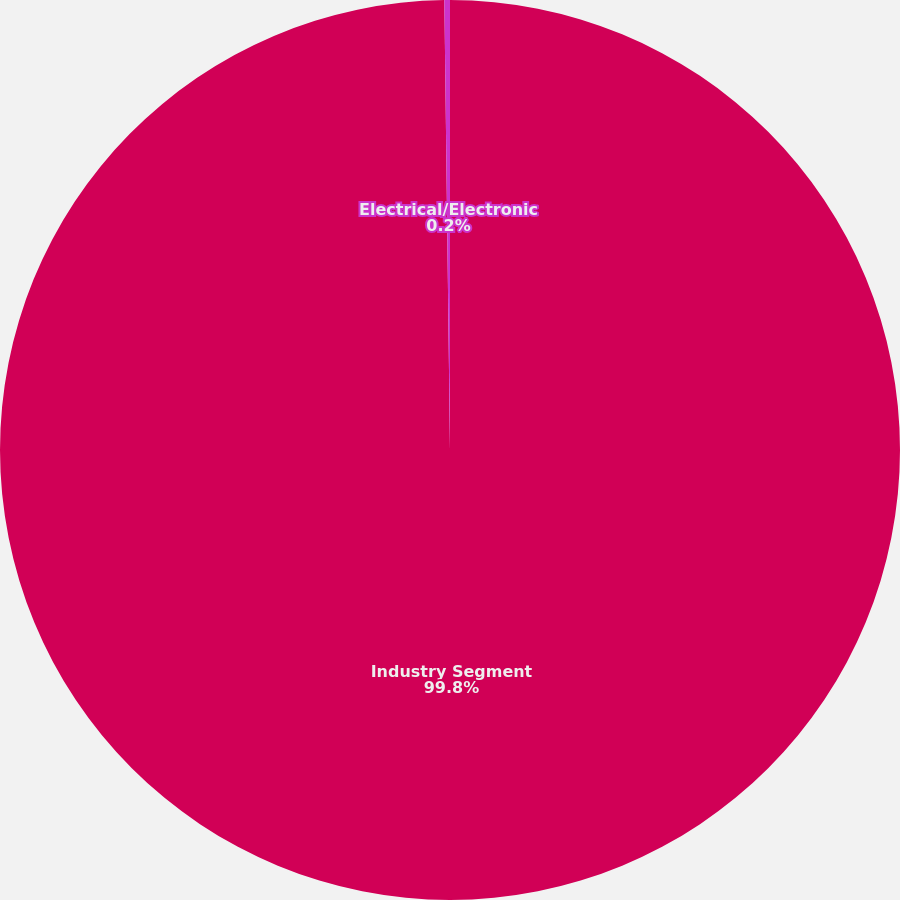Convert chart. <chart><loc_0><loc_0><loc_500><loc_500><pie_chart><fcel>Industry Segment<fcel>Electrical/Electronic<nl><fcel>99.8%<fcel>0.2%<nl></chart> 